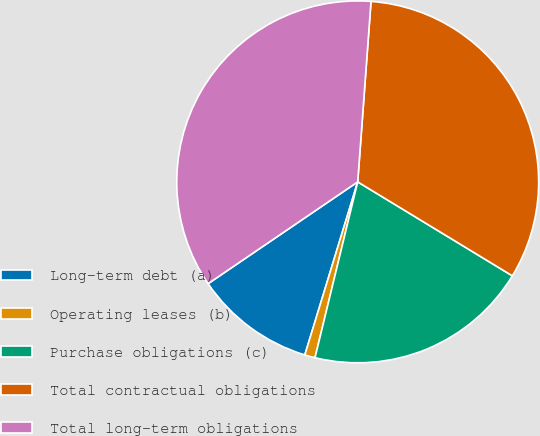Convert chart to OTSL. <chart><loc_0><loc_0><loc_500><loc_500><pie_chart><fcel>Long-term debt (a)<fcel>Operating leases (b)<fcel>Purchase obligations (c)<fcel>Total contractual obligations<fcel>Total long-term obligations<nl><fcel>10.77%<fcel>0.93%<fcel>20.1%<fcel>32.52%<fcel>35.68%<nl></chart> 